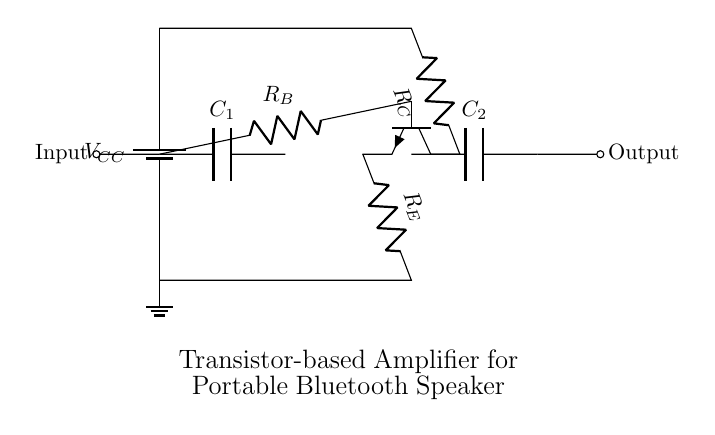What type of amplifier is shown in this circuit? The circuit is a transistor-based amplifier, which uses a transistor to increase the amplitude of signals.
Answer: Transistor-based amplifier What is the purpose of the resistors in this circuit? Resistors control the current flow in the circuit; specifically, the base resistor sets the input current to the transistor, while the collector and emitter resistors impact the output characteristics.
Answer: Current control Which component is used for input coupling? The coupling capacitor C1 is used to connect the input signal to the base of the transistor without passing any DC voltage.
Answer: Capacitor C1 What is the role of the transistor in this amplifier circuit? The transistor amplifies the input signal received at its base, allowing a larger output signal at its collector.
Answer: Signal amplification What connects the collector of the transistor to the power supply? The collector resistor R_C connects the collector pin to the voltage supply, providing a path for current when the transistor is conducting.
Answer: Collector resistor R_C How many capacitors are in the circuit? There are two capacitors in the circuit, C1 and C2, used for input and output coupling respectively.
Answer: Two capacitors What is the function of the emitter resistor in this circuit? The emitter resistor provides stability and helps set the gain of the amplifier, affecting the amount of feedback in the circuit.
Answer: Stability and gain 